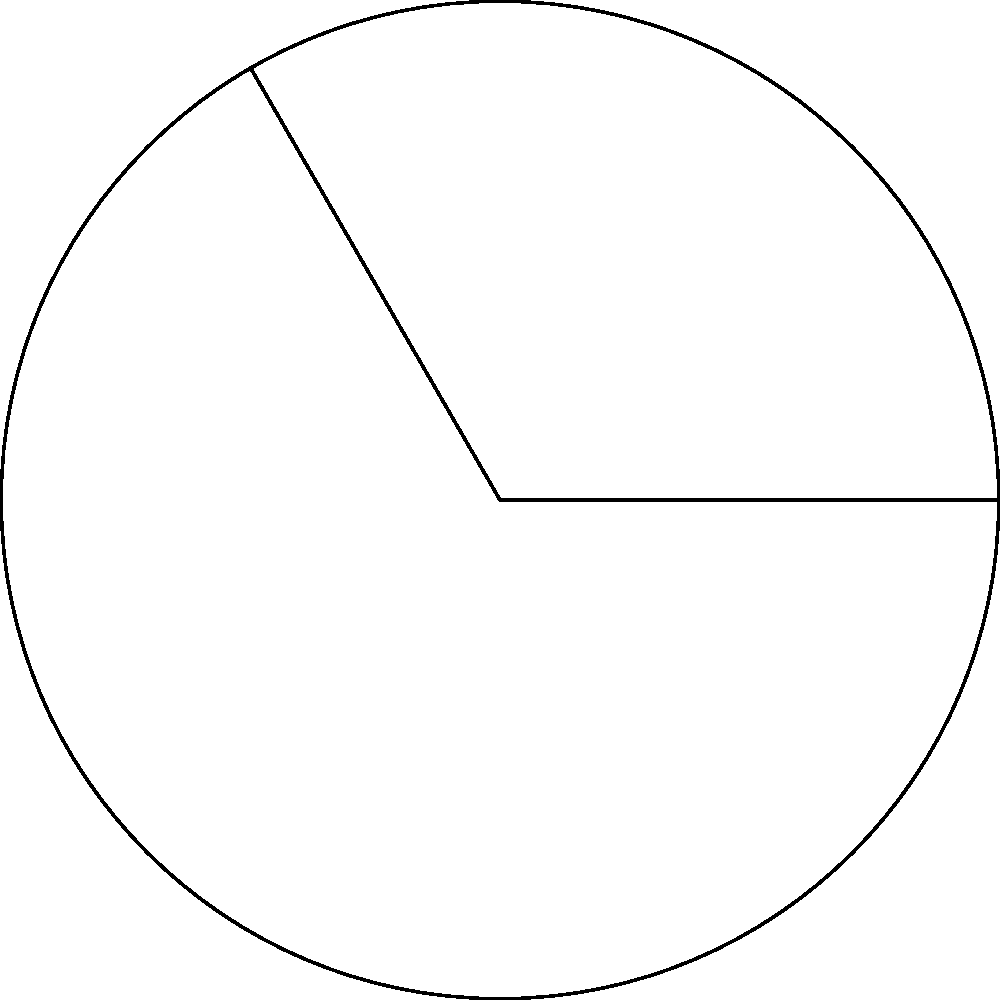In a futuristic space helmet design inspired by Dan Dare comics, the visor forms a circular sector with a central angle of $120°$ and a radius of $15$ cm. What is the area of the visor in square centimeters? To find the area of the circular sector (visor), we'll follow these steps:

1) The formula for the area of a circular sector is:
   $$A = \frac{\theta}{360°} \pi r^2$$
   where $\theta$ is the central angle in degrees and $r$ is the radius.

2) We're given:
   $\theta = 120°$
   $r = 15$ cm

3) Let's substitute these values into the formula:
   $$A = \frac{120°}{360°} \pi (15\text{ cm})^2$$

4) Simplify:
   $$A = \frac{1}{3} \pi (225\text{ cm}^2)$$

5) Calculate:
   $$A = 75\pi\text{ cm}^2 \approx 235.62\text{ cm}^2$$

Therefore, the area of the visor is $75\pi$ square centimeters or approximately 235.62 square centimeters.
Answer: $75\pi\text{ cm}^2$ 